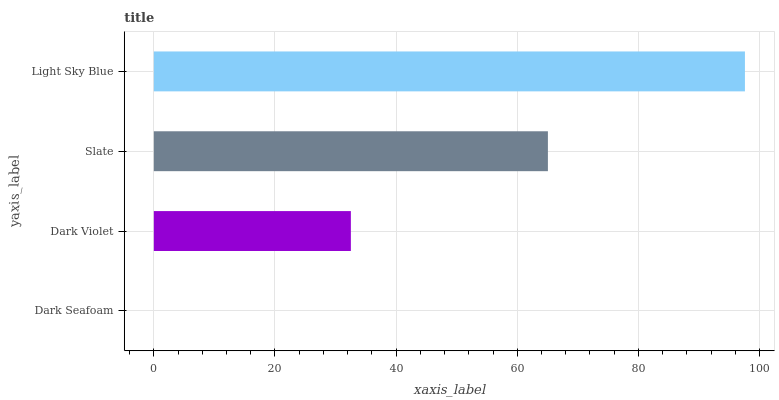Is Dark Seafoam the minimum?
Answer yes or no. Yes. Is Light Sky Blue the maximum?
Answer yes or no. Yes. Is Dark Violet the minimum?
Answer yes or no. No. Is Dark Violet the maximum?
Answer yes or no. No. Is Dark Violet greater than Dark Seafoam?
Answer yes or no. Yes. Is Dark Seafoam less than Dark Violet?
Answer yes or no. Yes. Is Dark Seafoam greater than Dark Violet?
Answer yes or no. No. Is Dark Violet less than Dark Seafoam?
Answer yes or no. No. Is Slate the high median?
Answer yes or no. Yes. Is Dark Violet the low median?
Answer yes or no. Yes. Is Dark Seafoam the high median?
Answer yes or no. No. Is Slate the low median?
Answer yes or no. No. 